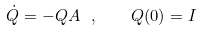Convert formula to latex. <formula><loc_0><loc_0><loc_500><loc_500>\dot { Q } = - Q A \ , \quad Q ( 0 ) = I</formula> 